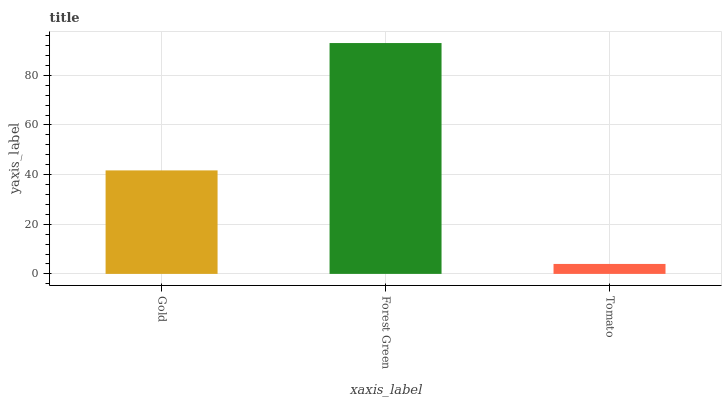Is Tomato the minimum?
Answer yes or no. Yes. Is Forest Green the maximum?
Answer yes or no. Yes. Is Forest Green the minimum?
Answer yes or no. No. Is Tomato the maximum?
Answer yes or no. No. Is Forest Green greater than Tomato?
Answer yes or no. Yes. Is Tomato less than Forest Green?
Answer yes or no. Yes. Is Tomato greater than Forest Green?
Answer yes or no. No. Is Forest Green less than Tomato?
Answer yes or no. No. Is Gold the high median?
Answer yes or no. Yes. Is Gold the low median?
Answer yes or no. Yes. Is Forest Green the high median?
Answer yes or no. No. Is Forest Green the low median?
Answer yes or no. No. 